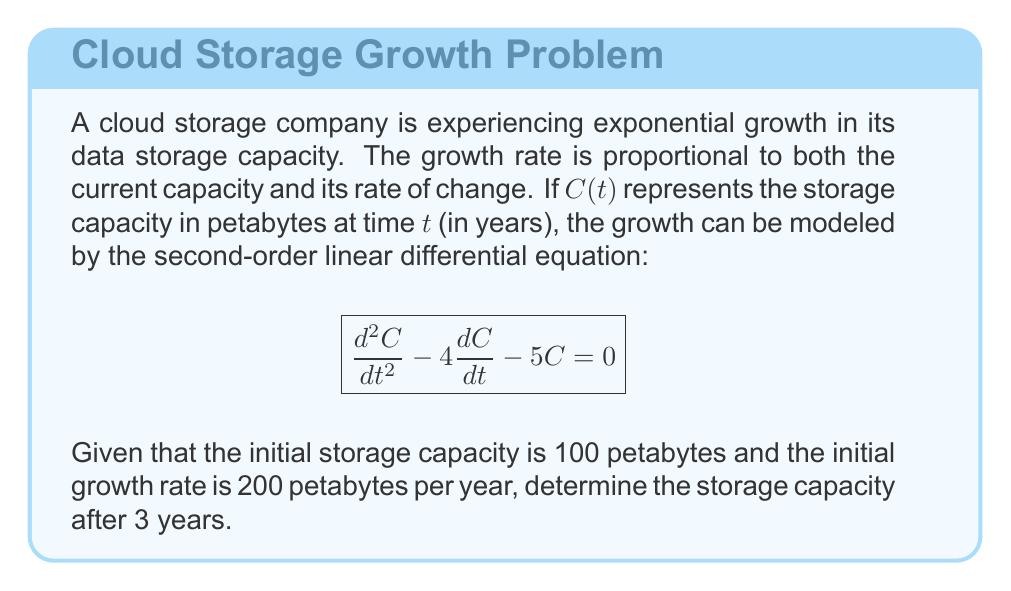Help me with this question. To solve this problem, we'll follow these steps:

1) The general solution for this second-order linear differential equation is:
   $$C(t) = A e^{5t} + B e^{-t}$$
   where $A$ and $B$ are constants we need to determine.

2) We have two initial conditions:
   $C(0) = 100$ (initial capacity)
   $C'(0) = 200$ (initial growth rate)

3) Let's use these conditions to find $A$ and $B$:
   
   For $C(0) = 100$:
   $$100 = A + B$$

   For $C'(0) = 200$:
   $$C'(t) = 5A e^{5t} - B e^{-t}$$
   $$200 = 5A - B$$

4) Solving these equations:
   $100 = A + B$
   $200 = 5A - B$
   
   Adding these equations:
   $300 = 6A$
   $A = 50$
   
   Substituting back:
   $100 = 50 + B$
   $B = 50$

5) Therefore, our specific solution is:
   $$C(t) = 50 e^{5t} + 50 e^{-t}$$

6) To find the capacity after 3 years, we calculate $C(3)$:
   $$C(3) = 50 e^{5(3)} + 50 e^{-3}$$
   $$= 50 e^{15} + 50 e^{-3}$$
   $$\approx 1.64 \times 10^8 + 2.47$$
   $$\approx 1.64 \times 10^8$$

Therefore, after 3 years, the storage capacity will be approximately 164 million petabytes.
Answer: $1.64 \times 10^8$ petabytes 